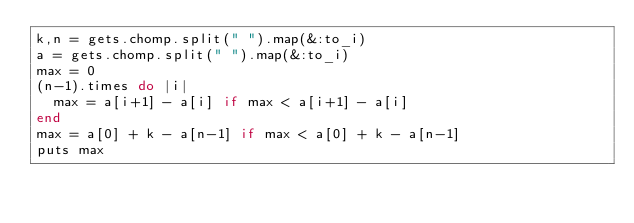Convert code to text. <code><loc_0><loc_0><loc_500><loc_500><_Ruby_>k,n = gets.chomp.split(" ").map(&:to_i)
a = gets.chomp.split(" ").map(&:to_i)
max = 0
(n-1).times do |i|
  max = a[i+1] - a[i] if max < a[i+1] - a[i]
end
max = a[0] + k - a[n-1] if max < a[0] + k - a[n-1]
puts max</code> 